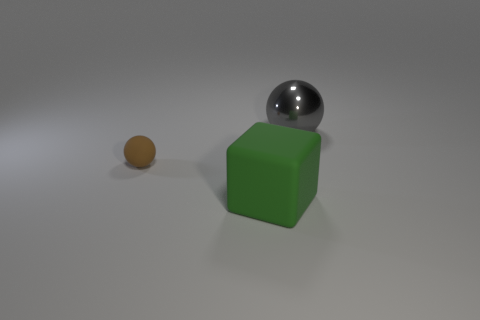Add 3 tiny blue matte cubes. How many objects exist? 6 Subtract all spheres. How many objects are left? 1 Add 1 green matte things. How many green matte things exist? 2 Subtract 0 green cylinders. How many objects are left? 3 Subtract all spheres. Subtract all brown matte things. How many objects are left? 0 Add 2 brown objects. How many brown objects are left? 3 